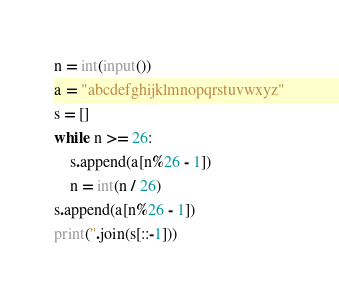<code> <loc_0><loc_0><loc_500><loc_500><_Python_>n = int(input())
a = "abcdefghijklmnopqrstuvwxyz"
s = []
while n >= 26:
    s.append(a[n%26 - 1])
    n = int(n / 26)
s.append(a[n%26 - 1])
print(''.join(s[::-1]))
</code> 